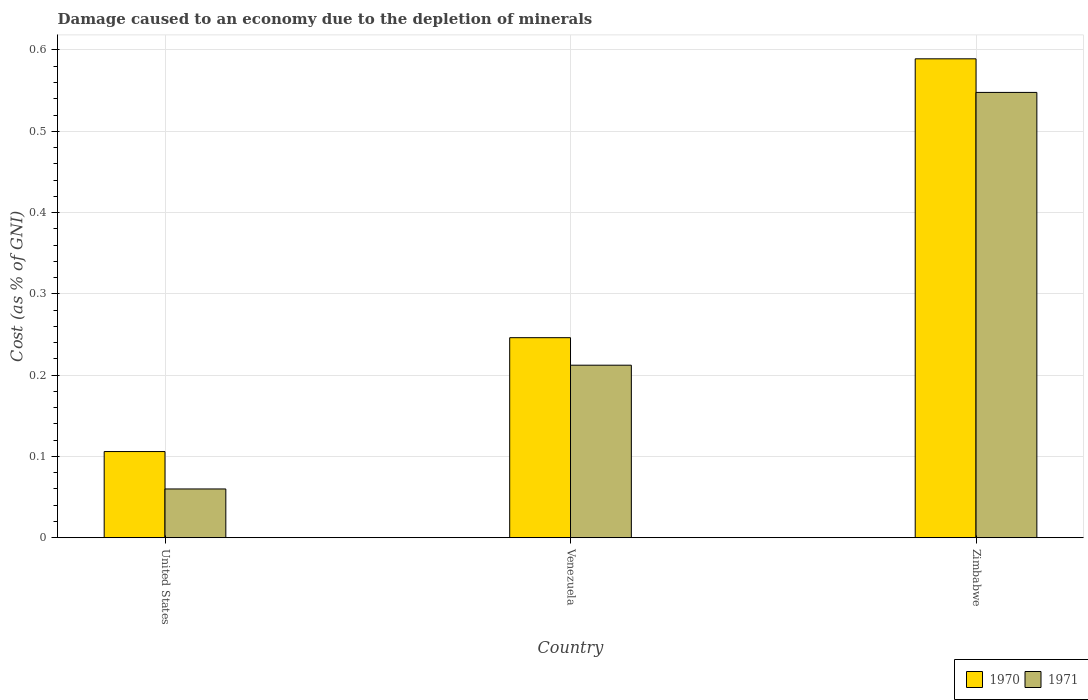Are the number of bars per tick equal to the number of legend labels?
Keep it short and to the point. Yes. Are the number of bars on each tick of the X-axis equal?
Provide a succinct answer. Yes. How many bars are there on the 3rd tick from the right?
Make the answer very short. 2. In how many cases, is the number of bars for a given country not equal to the number of legend labels?
Make the answer very short. 0. What is the cost of damage caused due to the depletion of minerals in 1971 in Venezuela?
Provide a succinct answer. 0.21. Across all countries, what is the maximum cost of damage caused due to the depletion of minerals in 1971?
Your answer should be compact. 0.55. Across all countries, what is the minimum cost of damage caused due to the depletion of minerals in 1971?
Provide a succinct answer. 0.06. In which country was the cost of damage caused due to the depletion of minerals in 1971 maximum?
Offer a terse response. Zimbabwe. What is the total cost of damage caused due to the depletion of minerals in 1971 in the graph?
Keep it short and to the point. 0.82. What is the difference between the cost of damage caused due to the depletion of minerals in 1971 in Venezuela and that in Zimbabwe?
Your response must be concise. -0.34. What is the difference between the cost of damage caused due to the depletion of minerals in 1971 in Zimbabwe and the cost of damage caused due to the depletion of minerals in 1970 in United States?
Offer a terse response. 0.44. What is the average cost of damage caused due to the depletion of minerals in 1971 per country?
Ensure brevity in your answer.  0.27. What is the difference between the cost of damage caused due to the depletion of minerals of/in 1970 and cost of damage caused due to the depletion of minerals of/in 1971 in United States?
Your answer should be compact. 0.05. What is the ratio of the cost of damage caused due to the depletion of minerals in 1971 in United States to that in Zimbabwe?
Your answer should be compact. 0.11. What is the difference between the highest and the second highest cost of damage caused due to the depletion of minerals in 1970?
Ensure brevity in your answer.  0.48. What is the difference between the highest and the lowest cost of damage caused due to the depletion of minerals in 1970?
Provide a succinct answer. 0.48. In how many countries, is the cost of damage caused due to the depletion of minerals in 1970 greater than the average cost of damage caused due to the depletion of minerals in 1970 taken over all countries?
Your answer should be compact. 1. Is the sum of the cost of damage caused due to the depletion of minerals in 1971 in United States and Venezuela greater than the maximum cost of damage caused due to the depletion of minerals in 1970 across all countries?
Your answer should be very brief. No. What does the 1st bar from the right in Venezuela represents?
Provide a succinct answer. 1971. How many bars are there?
Keep it short and to the point. 6. Are all the bars in the graph horizontal?
Make the answer very short. No. How many countries are there in the graph?
Offer a very short reply. 3. Does the graph contain grids?
Offer a very short reply. Yes. Where does the legend appear in the graph?
Offer a very short reply. Bottom right. How many legend labels are there?
Offer a very short reply. 2. What is the title of the graph?
Your answer should be compact. Damage caused to an economy due to the depletion of minerals. Does "1992" appear as one of the legend labels in the graph?
Provide a short and direct response. No. What is the label or title of the Y-axis?
Offer a very short reply. Cost (as % of GNI). What is the Cost (as % of GNI) in 1970 in United States?
Offer a very short reply. 0.11. What is the Cost (as % of GNI) of 1971 in United States?
Offer a very short reply. 0.06. What is the Cost (as % of GNI) in 1970 in Venezuela?
Offer a very short reply. 0.25. What is the Cost (as % of GNI) in 1971 in Venezuela?
Offer a very short reply. 0.21. What is the Cost (as % of GNI) in 1970 in Zimbabwe?
Ensure brevity in your answer.  0.59. What is the Cost (as % of GNI) of 1971 in Zimbabwe?
Ensure brevity in your answer.  0.55. Across all countries, what is the maximum Cost (as % of GNI) of 1970?
Offer a terse response. 0.59. Across all countries, what is the maximum Cost (as % of GNI) of 1971?
Offer a terse response. 0.55. Across all countries, what is the minimum Cost (as % of GNI) in 1970?
Offer a terse response. 0.11. Across all countries, what is the minimum Cost (as % of GNI) of 1971?
Make the answer very short. 0.06. What is the total Cost (as % of GNI) of 1971 in the graph?
Make the answer very short. 0.82. What is the difference between the Cost (as % of GNI) in 1970 in United States and that in Venezuela?
Make the answer very short. -0.14. What is the difference between the Cost (as % of GNI) of 1971 in United States and that in Venezuela?
Your answer should be very brief. -0.15. What is the difference between the Cost (as % of GNI) in 1970 in United States and that in Zimbabwe?
Keep it short and to the point. -0.48. What is the difference between the Cost (as % of GNI) of 1971 in United States and that in Zimbabwe?
Offer a very short reply. -0.49. What is the difference between the Cost (as % of GNI) in 1970 in Venezuela and that in Zimbabwe?
Offer a very short reply. -0.34. What is the difference between the Cost (as % of GNI) in 1971 in Venezuela and that in Zimbabwe?
Offer a very short reply. -0.34. What is the difference between the Cost (as % of GNI) in 1970 in United States and the Cost (as % of GNI) in 1971 in Venezuela?
Offer a very short reply. -0.11. What is the difference between the Cost (as % of GNI) in 1970 in United States and the Cost (as % of GNI) in 1971 in Zimbabwe?
Make the answer very short. -0.44. What is the difference between the Cost (as % of GNI) in 1970 in Venezuela and the Cost (as % of GNI) in 1971 in Zimbabwe?
Provide a short and direct response. -0.3. What is the average Cost (as % of GNI) of 1970 per country?
Offer a very short reply. 0.31. What is the average Cost (as % of GNI) in 1971 per country?
Your answer should be compact. 0.27. What is the difference between the Cost (as % of GNI) in 1970 and Cost (as % of GNI) in 1971 in United States?
Provide a short and direct response. 0.05. What is the difference between the Cost (as % of GNI) of 1970 and Cost (as % of GNI) of 1971 in Venezuela?
Keep it short and to the point. 0.03. What is the difference between the Cost (as % of GNI) of 1970 and Cost (as % of GNI) of 1971 in Zimbabwe?
Offer a terse response. 0.04. What is the ratio of the Cost (as % of GNI) of 1970 in United States to that in Venezuela?
Make the answer very short. 0.43. What is the ratio of the Cost (as % of GNI) of 1971 in United States to that in Venezuela?
Provide a succinct answer. 0.28. What is the ratio of the Cost (as % of GNI) in 1970 in United States to that in Zimbabwe?
Make the answer very short. 0.18. What is the ratio of the Cost (as % of GNI) in 1971 in United States to that in Zimbabwe?
Provide a short and direct response. 0.11. What is the ratio of the Cost (as % of GNI) of 1970 in Venezuela to that in Zimbabwe?
Your response must be concise. 0.42. What is the ratio of the Cost (as % of GNI) of 1971 in Venezuela to that in Zimbabwe?
Your answer should be compact. 0.39. What is the difference between the highest and the second highest Cost (as % of GNI) of 1970?
Make the answer very short. 0.34. What is the difference between the highest and the second highest Cost (as % of GNI) in 1971?
Give a very brief answer. 0.34. What is the difference between the highest and the lowest Cost (as % of GNI) of 1970?
Provide a succinct answer. 0.48. What is the difference between the highest and the lowest Cost (as % of GNI) in 1971?
Your response must be concise. 0.49. 